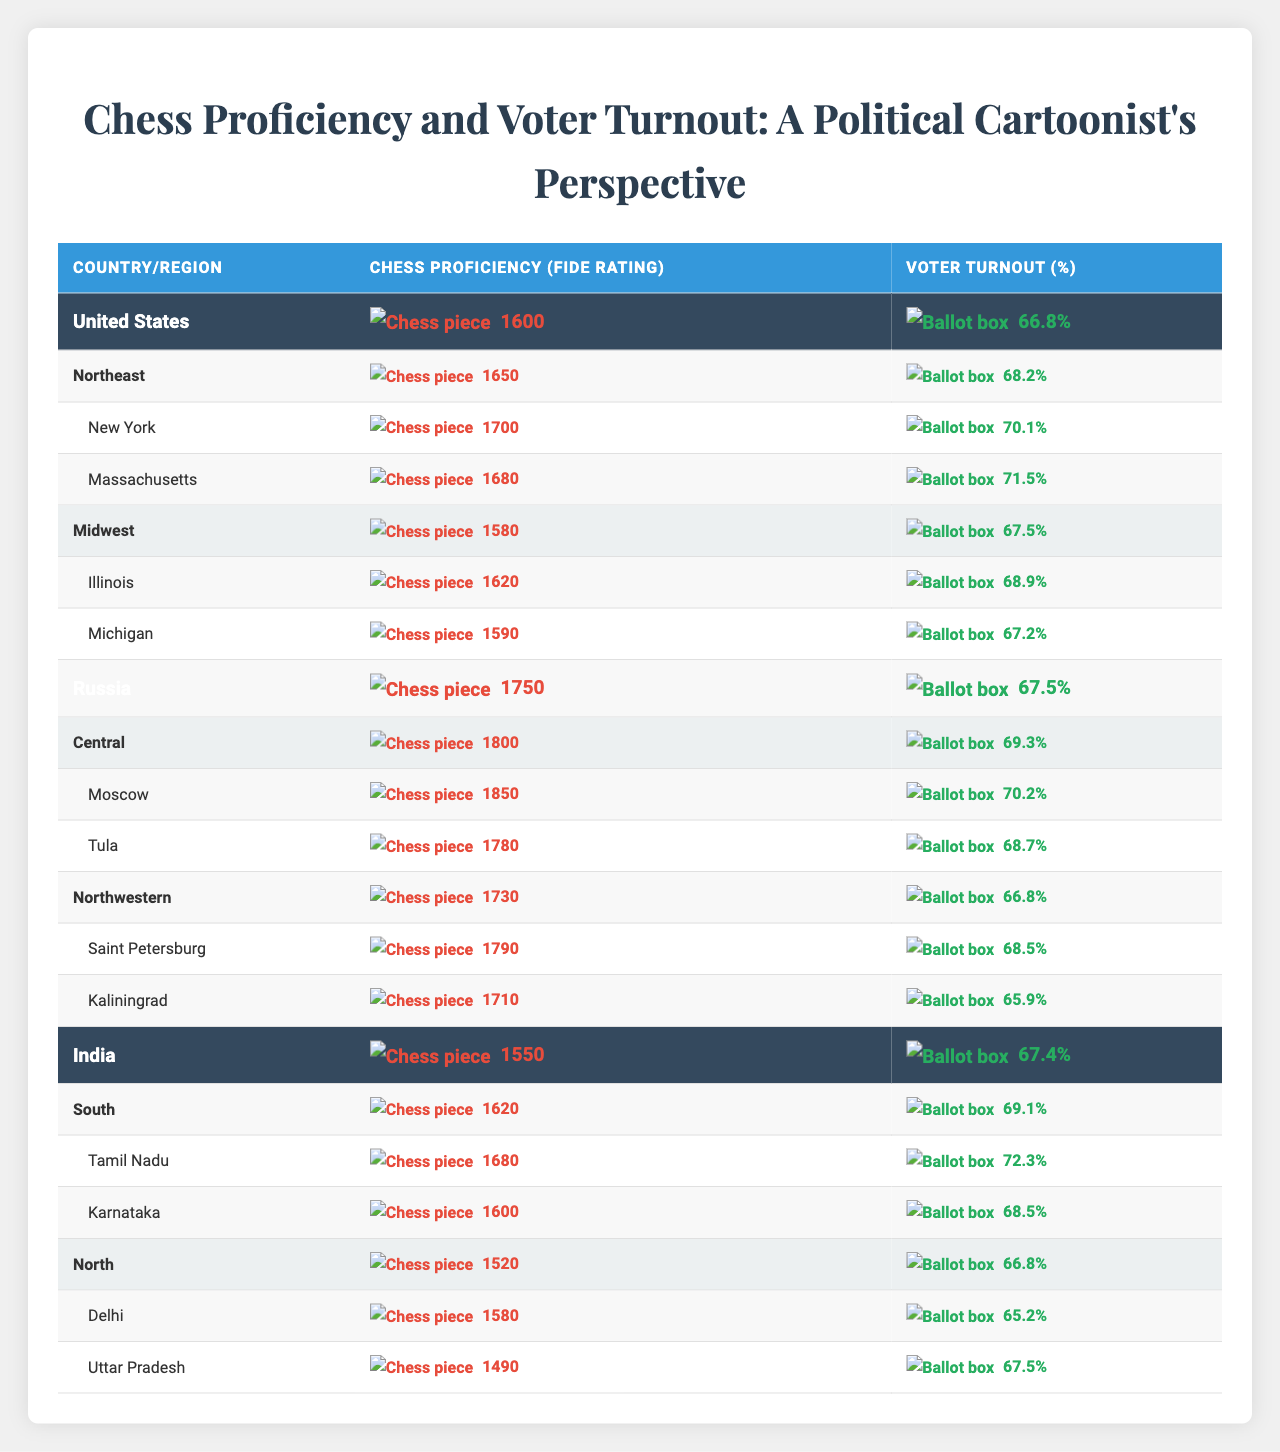What is the average chess proficiency rating in the United States? The average chess proficiency rating for the United States is given directly in the table as 1600.
Answer: 1600 Which region in Russia has the highest chess proficiency? From the table, the Central region in Russia shows a chess proficiency of 1800, which is higher than any other region listed.
Answer: Central What is the voter turnout percentage in California? California is not listed in the provided data, thus no voter turnout percentage can be determined from the table.
Answer: Not applicable What is the difference in chess proficiency between the Midwest and Northeast regions in the United States? The chess proficiency in the Northeast is 1650 and in the Midwest is 1580. Thus, the difference is 1650 - 1580 = 70.
Answer: 70 Does India have a higher average voter turnout compared to the United States? India's average voter turnout is 67.4%, while the United States has 66.8%, therefore India has a higher average voter turnout.
Answer: Yes What is the chess proficiency rating of Tamil Nadu? Tamil Nadu’s chess proficiency rating is specifically listed in the table as 1680.
Answer: 1680 Calculate the average chess proficiency rating across all regions in India. The chess proficiency ratings for the South region (1620) and North region (1520) can be averaged as follows: (1620 + 1520) / 2 = 1570.
Answer: 1570 Which city in Russia has the highest voter turnout? By comparing the cities listed under Russia's regions, Moscow shows a voter turnout of 70.2%, which is greater than others.
Answer: Moscow Is the average voter turnout in India less than that in Russia? India's average voter turnout is 67.4%, and Russia's is 67.5%; hence, India's is indeed less than Russia's.
Answer: Yes How does the chess proficiency rating of Illinois compare to the average for the entire United States? Illinois has a chess proficiency rating of 1620, which is higher than the U.S. average of 1600. Thus, Illinois is above average.
Answer: Higher than average 